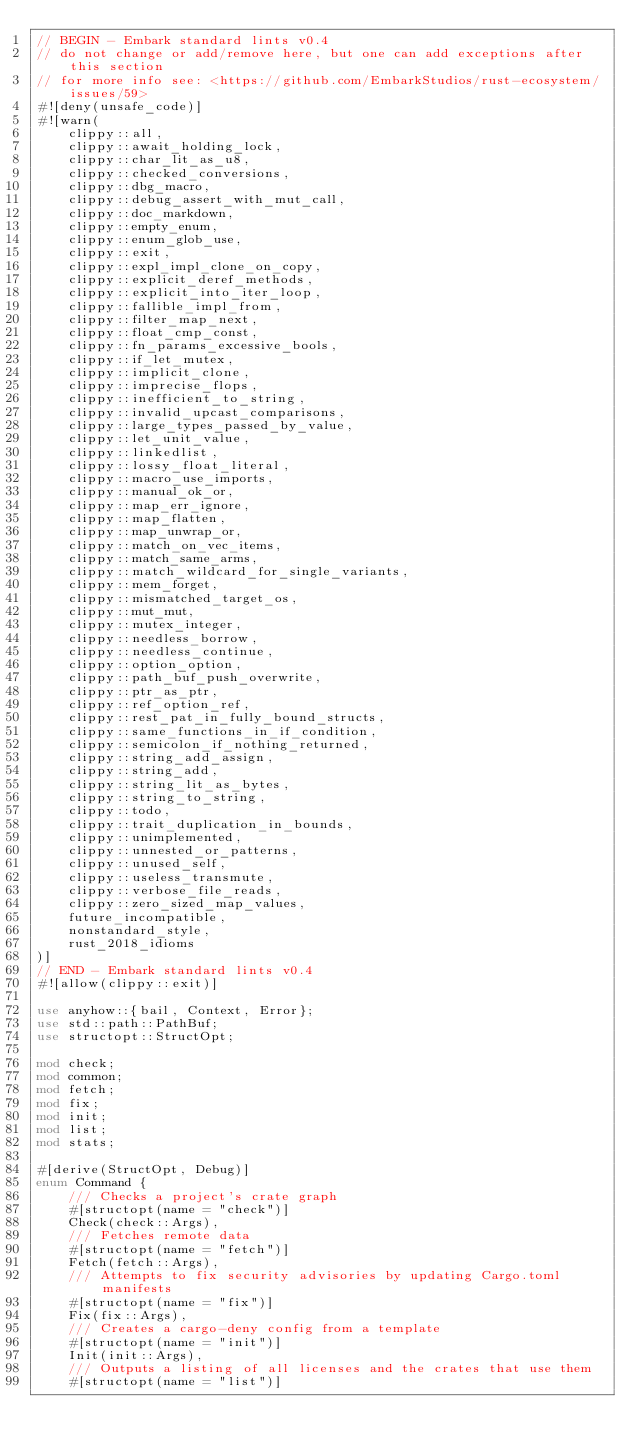Convert code to text. <code><loc_0><loc_0><loc_500><loc_500><_Rust_>// BEGIN - Embark standard lints v0.4
// do not change or add/remove here, but one can add exceptions after this section
// for more info see: <https://github.com/EmbarkStudios/rust-ecosystem/issues/59>
#![deny(unsafe_code)]
#![warn(
    clippy::all,
    clippy::await_holding_lock,
    clippy::char_lit_as_u8,
    clippy::checked_conversions,
    clippy::dbg_macro,
    clippy::debug_assert_with_mut_call,
    clippy::doc_markdown,
    clippy::empty_enum,
    clippy::enum_glob_use,
    clippy::exit,
    clippy::expl_impl_clone_on_copy,
    clippy::explicit_deref_methods,
    clippy::explicit_into_iter_loop,
    clippy::fallible_impl_from,
    clippy::filter_map_next,
    clippy::float_cmp_const,
    clippy::fn_params_excessive_bools,
    clippy::if_let_mutex,
    clippy::implicit_clone,
    clippy::imprecise_flops,
    clippy::inefficient_to_string,
    clippy::invalid_upcast_comparisons,
    clippy::large_types_passed_by_value,
    clippy::let_unit_value,
    clippy::linkedlist,
    clippy::lossy_float_literal,
    clippy::macro_use_imports,
    clippy::manual_ok_or,
    clippy::map_err_ignore,
    clippy::map_flatten,
    clippy::map_unwrap_or,
    clippy::match_on_vec_items,
    clippy::match_same_arms,
    clippy::match_wildcard_for_single_variants,
    clippy::mem_forget,
    clippy::mismatched_target_os,
    clippy::mut_mut,
    clippy::mutex_integer,
    clippy::needless_borrow,
    clippy::needless_continue,
    clippy::option_option,
    clippy::path_buf_push_overwrite,
    clippy::ptr_as_ptr,
    clippy::ref_option_ref,
    clippy::rest_pat_in_fully_bound_structs,
    clippy::same_functions_in_if_condition,
    clippy::semicolon_if_nothing_returned,
    clippy::string_add_assign,
    clippy::string_add,
    clippy::string_lit_as_bytes,
    clippy::string_to_string,
    clippy::todo,
    clippy::trait_duplication_in_bounds,
    clippy::unimplemented,
    clippy::unnested_or_patterns,
    clippy::unused_self,
    clippy::useless_transmute,
    clippy::verbose_file_reads,
    clippy::zero_sized_map_values,
    future_incompatible,
    nonstandard_style,
    rust_2018_idioms
)]
// END - Embark standard lints v0.4
#![allow(clippy::exit)]

use anyhow::{bail, Context, Error};
use std::path::PathBuf;
use structopt::StructOpt;

mod check;
mod common;
mod fetch;
mod fix;
mod init;
mod list;
mod stats;

#[derive(StructOpt, Debug)]
enum Command {
    /// Checks a project's crate graph
    #[structopt(name = "check")]
    Check(check::Args),
    /// Fetches remote data
    #[structopt(name = "fetch")]
    Fetch(fetch::Args),
    /// Attempts to fix security advisories by updating Cargo.toml manifests
    #[structopt(name = "fix")]
    Fix(fix::Args),
    /// Creates a cargo-deny config from a template
    #[structopt(name = "init")]
    Init(init::Args),
    /// Outputs a listing of all licenses and the crates that use them
    #[structopt(name = "list")]</code> 